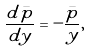<formula> <loc_0><loc_0><loc_500><loc_500>\frac { d \bar { p } } { d y } = - \frac { \bar { p } } { y } ,</formula> 